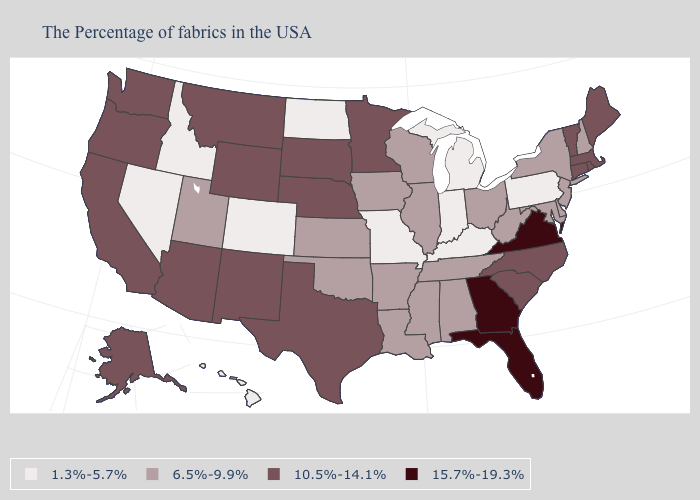Among the states that border Connecticut , does Massachusetts have the highest value?
Quick response, please. Yes. Name the states that have a value in the range 1.3%-5.7%?
Concise answer only. Pennsylvania, Michigan, Kentucky, Indiana, Missouri, North Dakota, Colorado, Idaho, Nevada, Hawaii. Does Virginia have the highest value in the USA?
Be succinct. Yes. Name the states that have a value in the range 15.7%-19.3%?
Give a very brief answer. Virginia, Florida, Georgia. What is the highest value in states that border Texas?
Concise answer only. 10.5%-14.1%. Name the states that have a value in the range 15.7%-19.3%?
Quick response, please. Virginia, Florida, Georgia. What is the value of Tennessee?
Give a very brief answer. 6.5%-9.9%. Does Utah have the lowest value in the West?
Answer briefly. No. Is the legend a continuous bar?
Give a very brief answer. No. What is the value of Rhode Island?
Quick response, please. 10.5%-14.1%. What is the value of Pennsylvania?
Keep it brief. 1.3%-5.7%. Does Indiana have the lowest value in the MidWest?
Short answer required. Yes. Name the states that have a value in the range 15.7%-19.3%?
Quick response, please. Virginia, Florida, Georgia. What is the highest value in the South ?
Write a very short answer. 15.7%-19.3%. Does the map have missing data?
Answer briefly. No. 